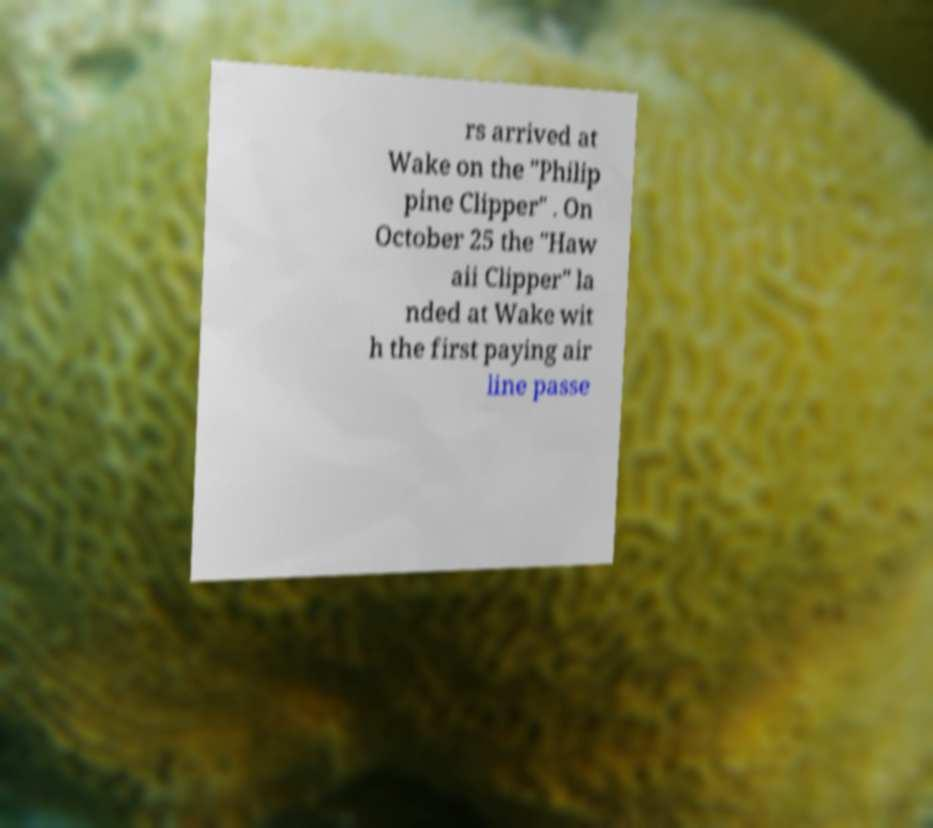Please read and relay the text visible in this image. What does it say? rs arrived at Wake on the "Philip pine Clipper" . On October 25 the "Haw aii Clipper" la nded at Wake wit h the first paying air line passe 